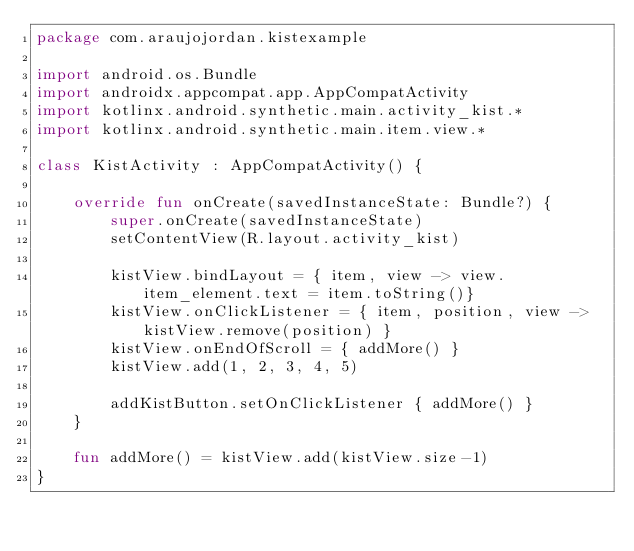Convert code to text. <code><loc_0><loc_0><loc_500><loc_500><_Kotlin_>package com.araujojordan.kistexample

import android.os.Bundle
import androidx.appcompat.app.AppCompatActivity
import kotlinx.android.synthetic.main.activity_kist.*
import kotlinx.android.synthetic.main.item.view.*

class KistActivity : AppCompatActivity() {

    override fun onCreate(savedInstanceState: Bundle?) {
        super.onCreate(savedInstanceState)
        setContentView(R.layout.activity_kist)

        kistView.bindLayout = { item, view -> view.item_element.text = item.toString()}
        kistView.onClickListener = { item, position, view ->  kistView.remove(position) }
        kistView.onEndOfScroll = { addMore() }
        kistView.add(1, 2, 3, 4, 5)

        addKistButton.setOnClickListener { addMore() }
    }

    fun addMore() = kistView.add(kistView.size-1)
}
</code> 